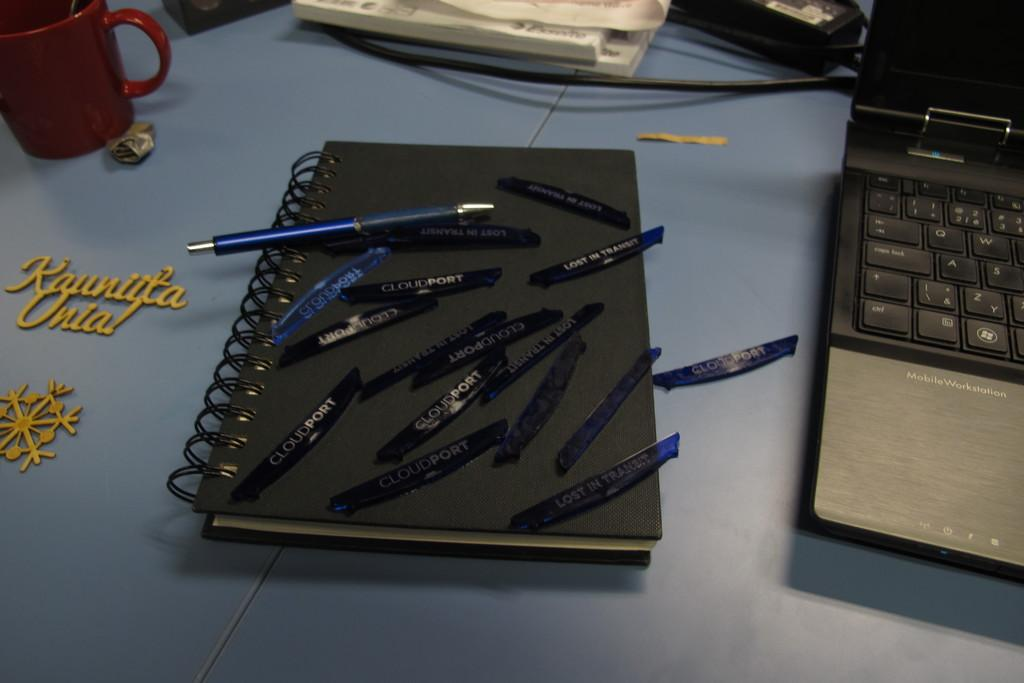What piece of furniture is present in the image? There is a table in the image. What electronic device can be seen on the table? There is a laptop on the right side of the table. What type of items are also present on the table? There are books, a mug, a wire, name plates, and a pen on a book on the table. What type of cloth is used to cover the laptop in the image? There is no cloth covering the laptop in the image; it is visible on the table. 